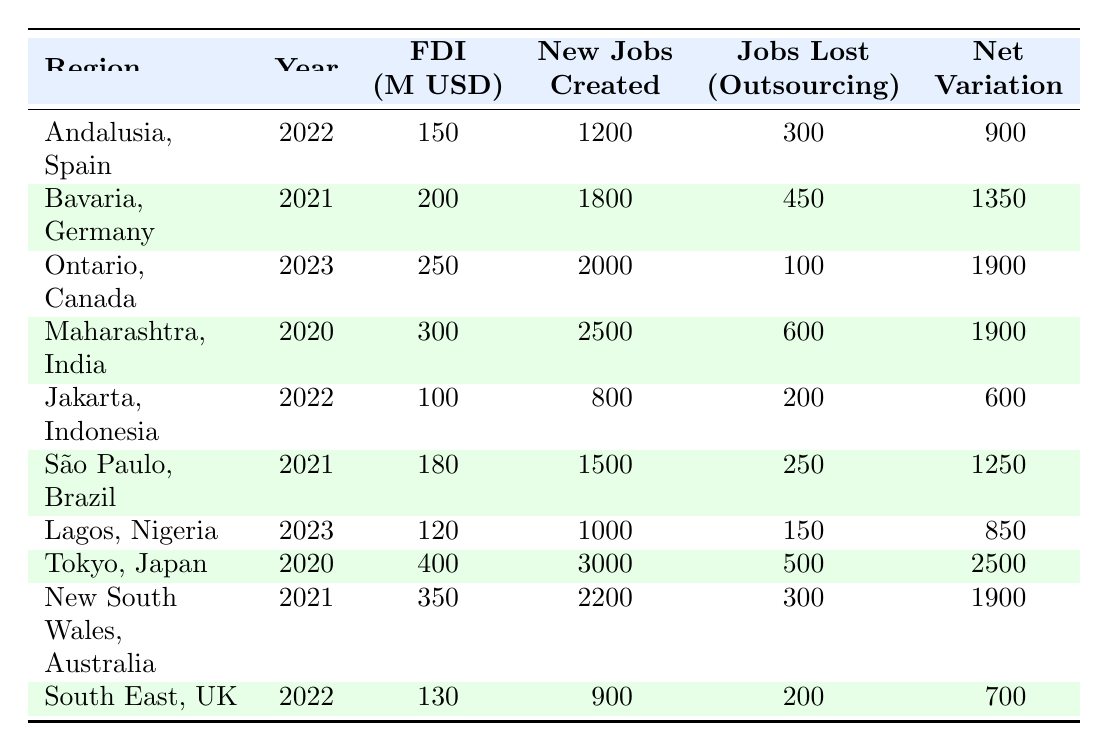What is the net employment variation for Maharashtra, India in 2020? The net employment variation for Maharashtra, India in 2020 is listed in the table. It shows a value of 1900.
Answer: 1900 Which region had the highest foreign direct investment in 2020? According to the table, Tokyo, Japan had the highest foreign direct investment in 2020 with 400 million USD.
Answer: Tokyo, Japan How many new jobs were created in Ontario, Canada in 2023? The table specifies that Ontario, Canada created 2000 new jobs in 2023.
Answer: 2000 What is the net employment variation for Andalusia, Spain in 2022? The table indicates that net employment variation in Andalusia, Spain in 2022 is 900.
Answer: 900 Which region had the least jobs lost due to outsourcing in 2022? In 2022, Jakarta, Indonesia had the least jobs lost due to outsourcing, with a count of 200.
Answer: Jakarta, Indonesia Calculate the total net employment variation for all regions listed in the table. By adding up the net employment variations: 900 + 1350 + 1900 + 1900 + 600 + 1250 + 850 + 2500 + 1900 + 700 = 12,900. Therefore, the total is 12,900.
Answer: 12,900 Which region had the highest net employment variation and what is that value? Looking at the net employment variation column, Tokyo, Japan has the highest value at 2500.
Answer: 2500 Is the total new jobs created across all regions more than 10,000? Summing the new jobs created: 1200 + 1800 + 2000 + 2500 + 800 + 1500 + 1000 + 3000 + 2200 + 900 = 18500, which is greater than 10,000.
Answer: Yes How many regions experienced a net employment variation greater than 1500? By reviewing the net employment variation values, the regions with more than 1500 are: Maharashtra, India (1900), Ontario, Canada (1900), and Tokyo, Japan (2500). Thus, there are 3 regions.
Answer: 3 What is the difference in foreign investment between Lagos, Nigeria and São Paulo, Brazil? Lagos, Nigeria has foreign investment of 120 million USD while São Paulo, Brazil has 180 million USD. The difference is calculated as 180 - 120 = 60 million USD.
Answer: 60 million USD 